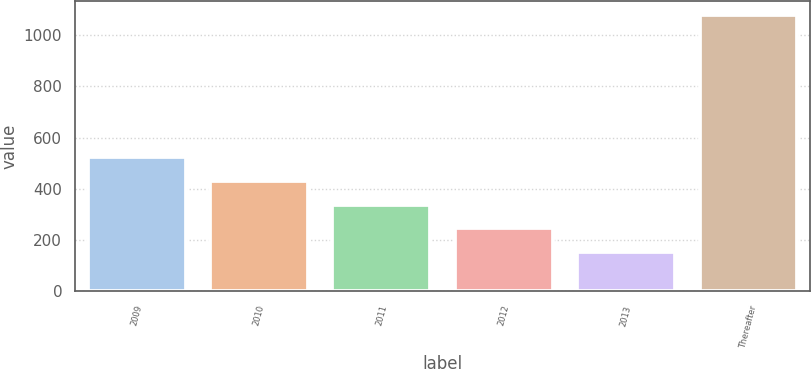Convert chart. <chart><loc_0><loc_0><loc_500><loc_500><bar_chart><fcel>2009<fcel>2010<fcel>2011<fcel>2012<fcel>2013<fcel>Thereafter<nl><fcel>523.2<fcel>430.4<fcel>337.6<fcel>244.8<fcel>152<fcel>1080<nl></chart> 